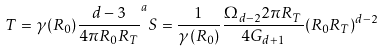Convert formula to latex. <formula><loc_0><loc_0><loc_500><loc_500>T = \gamma ( R _ { 0 } ) \frac { d - 3 } { 4 \pi R _ { 0 } R _ { T } } ^ { a } S = \frac { 1 } { \gamma ( R _ { 0 } ) } \frac { \Omega _ { d - 2 } 2 \pi R _ { T } } { 4 G _ { d + 1 } } ( R _ { 0 } R _ { T } ) ^ { d - 2 }</formula> 